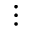Convert formula to latex. <formula><loc_0><loc_0><loc_500><loc_500>\vdots</formula> 